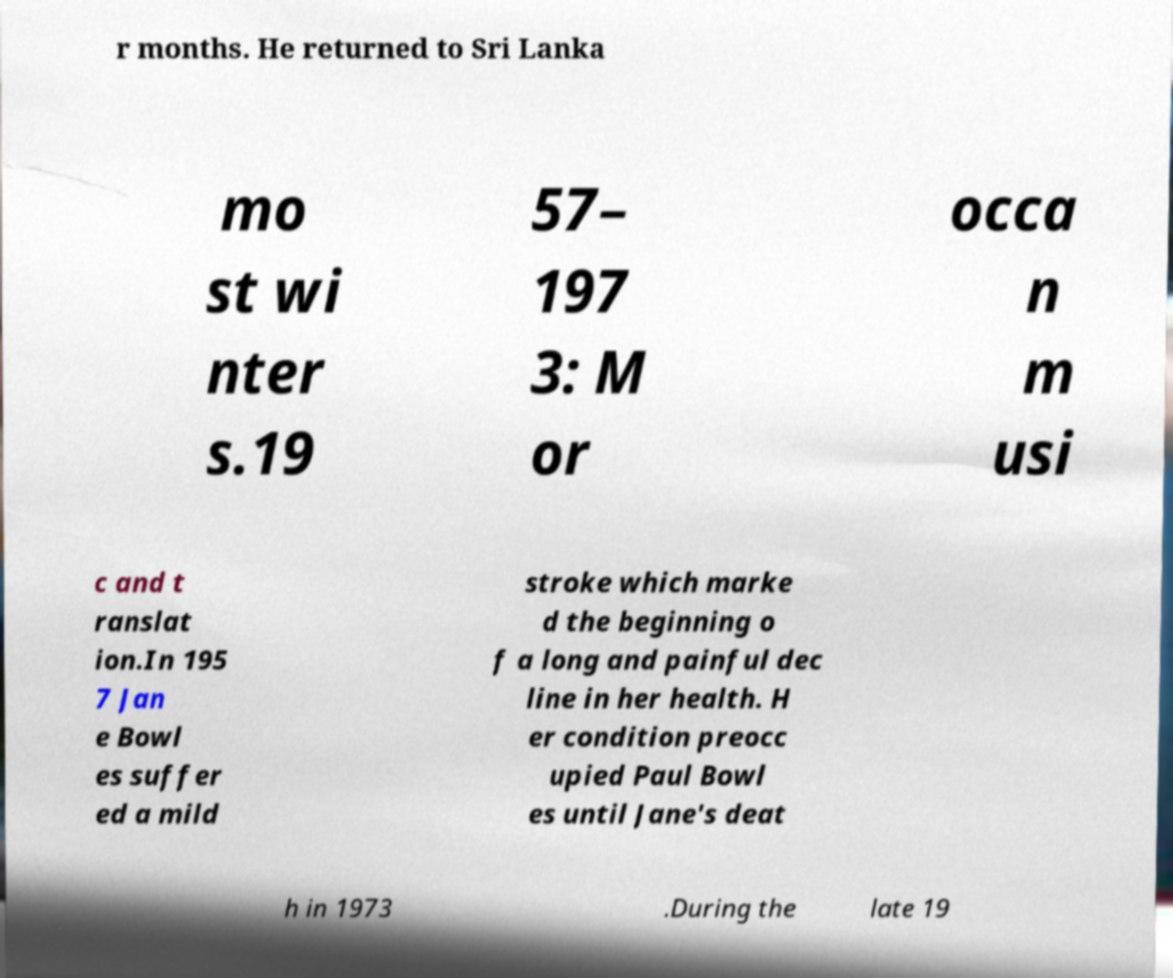Please identify and transcribe the text found in this image. r months. He returned to Sri Lanka mo st wi nter s.19 57– 197 3: M or occa n m usi c and t ranslat ion.In 195 7 Jan e Bowl es suffer ed a mild stroke which marke d the beginning o f a long and painful dec line in her health. H er condition preocc upied Paul Bowl es until Jane's deat h in 1973 .During the late 19 